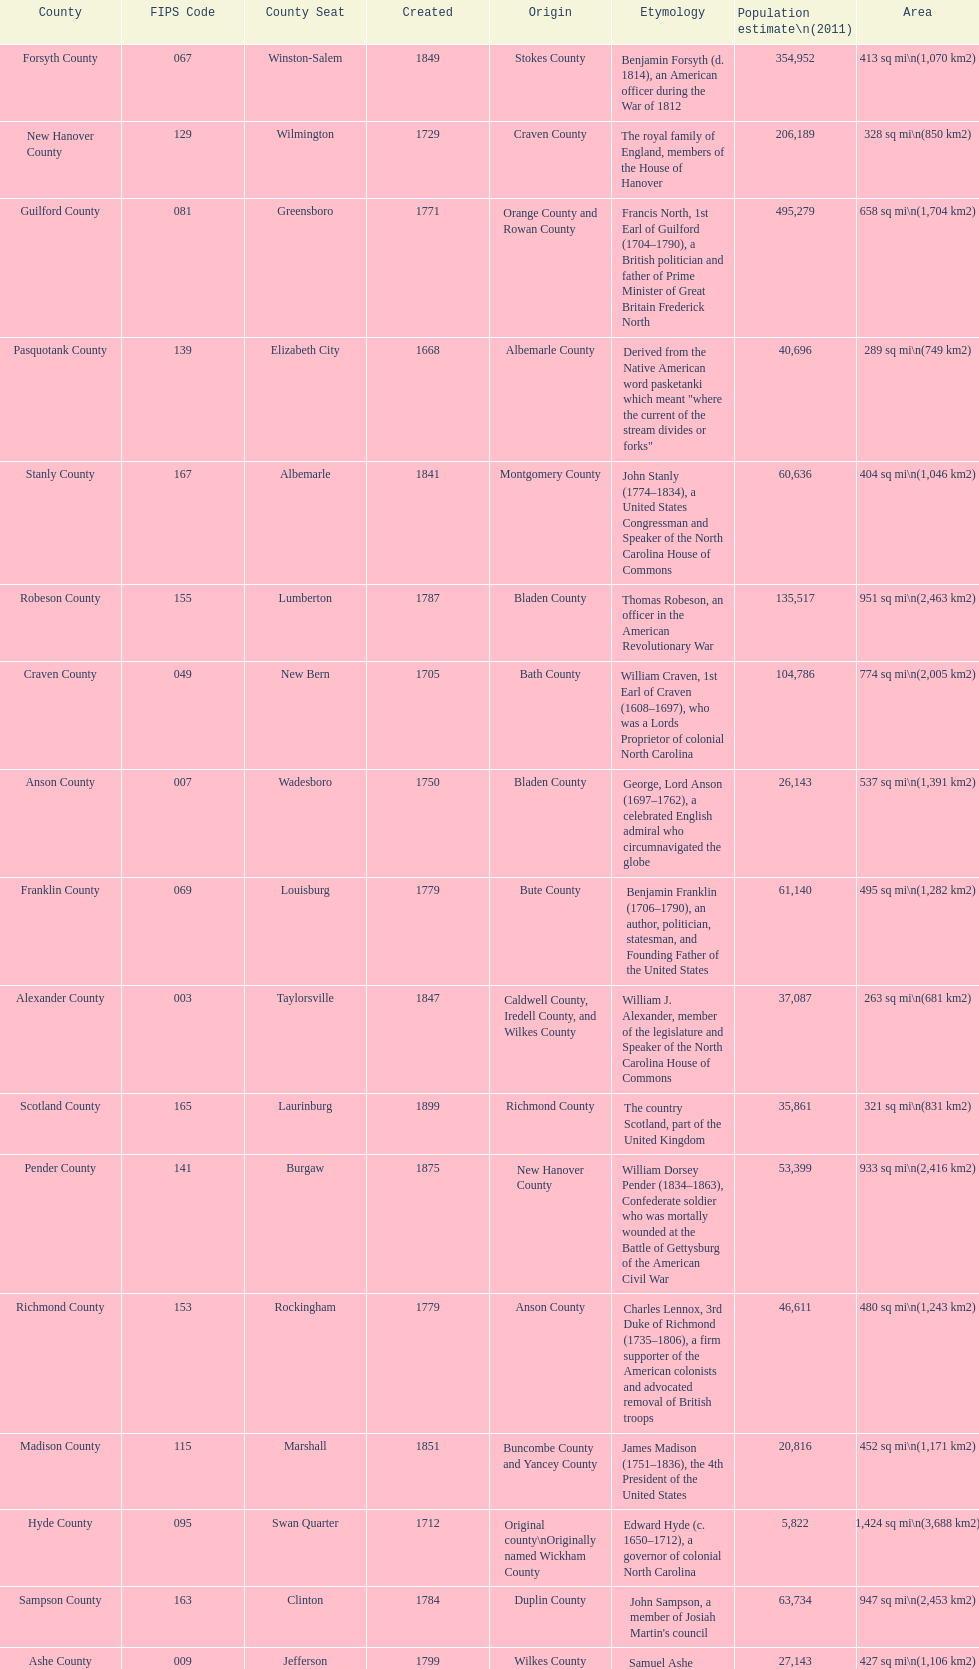What number of counties are named for us presidents? 3. 